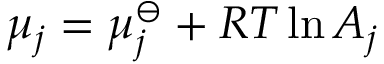Convert formula to latex. <formula><loc_0><loc_0><loc_500><loc_500>\mu _ { j } = \mu _ { j } ^ { \ominus } + R T \ln { A _ { j } }</formula> 